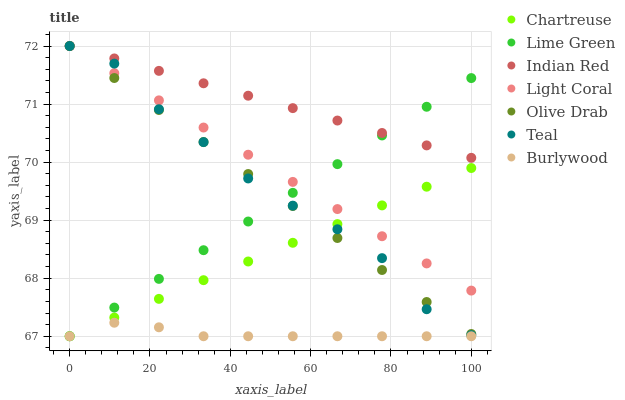Does Burlywood have the minimum area under the curve?
Answer yes or no. Yes. Does Indian Red have the maximum area under the curve?
Answer yes or no. Yes. Does Light Coral have the minimum area under the curve?
Answer yes or no. No. Does Light Coral have the maximum area under the curve?
Answer yes or no. No. Is Lime Green the smoothest?
Answer yes or no. Yes. Is Teal the roughest?
Answer yes or no. Yes. Is Burlywood the smoothest?
Answer yes or no. No. Is Burlywood the roughest?
Answer yes or no. No. Does Burlywood have the lowest value?
Answer yes or no. Yes. Does Light Coral have the lowest value?
Answer yes or no. No. Does Olive Drab have the highest value?
Answer yes or no. Yes. Does Burlywood have the highest value?
Answer yes or no. No. Is Chartreuse less than Indian Red?
Answer yes or no. Yes. Is Indian Red greater than Chartreuse?
Answer yes or no. Yes. Does Chartreuse intersect Lime Green?
Answer yes or no. Yes. Is Chartreuse less than Lime Green?
Answer yes or no. No. Is Chartreuse greater than Lime Green?
Answer yes or no. No. Does Chartreuse intersect Indian Red?
Answer yes or no. No. 